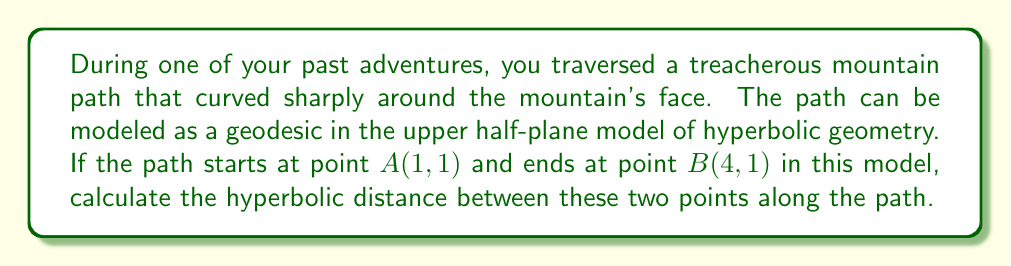Show me your answer to this math problem. To solve this problem, we'll use the formula for hyperbolic distance in the upper half-plane model. The steps are as follows:

1) In the upper half-plane model, the hyperbolic distance $d$ between two points $(x_1,y_1)$ and $(x_2,y_2)$ is given by:

   $$d = \text{arcosh}\left(1 + \frac{(x_2-x_1)^2 + (y_2-y_1)^2}{2y_1y_2}\right)$$

   where arcosh is the inverse hyperbolic cosine function.

2) We have $A(1,1)$ and $B(4,1)$, so:
   $x_1 = 1$, $y_1 = 1$, $x_2 = 4$, $y_2 = 1$

3) Let's substitute these values into our formula:

   $$d = \text{arcosh}\left(1 + \frac{(4-1)^2 + (1-1)^2}{2(1)(1)}\right)$$

4) Simplify:
   $$d = \text{arcosh}\left(1 + \frac{9 + 0}{2}\right) = \text{arcosh}\left(1 + \frac{9}{2}\right) = \text{arcosh}(5.5)$$

5) The value of arcosh(5.5) can be calculated using a calculator or computer.
Answer: $\text{arcosh}(5.5) \approx 2.478$ 